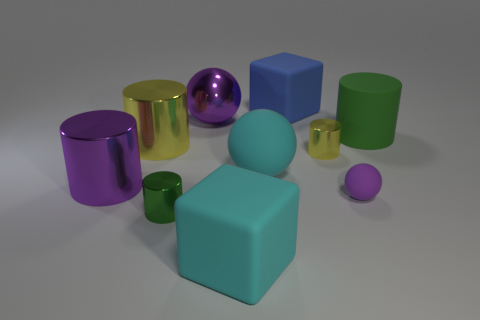Are there any patterns or textures on any of the objects? No, all the objects in the image have a smooth finish without any visible patterns or textures. Each object reflects light differently due to their unique material properties, which gives them a distinctive look. Which object appears to have the smoothest surface? The metallic purple sphere appears to have the smoothest surface, reflected in its high gloss finish and clear reflections. The smoothness accentuates its round shape and gives it a pristine quality. 